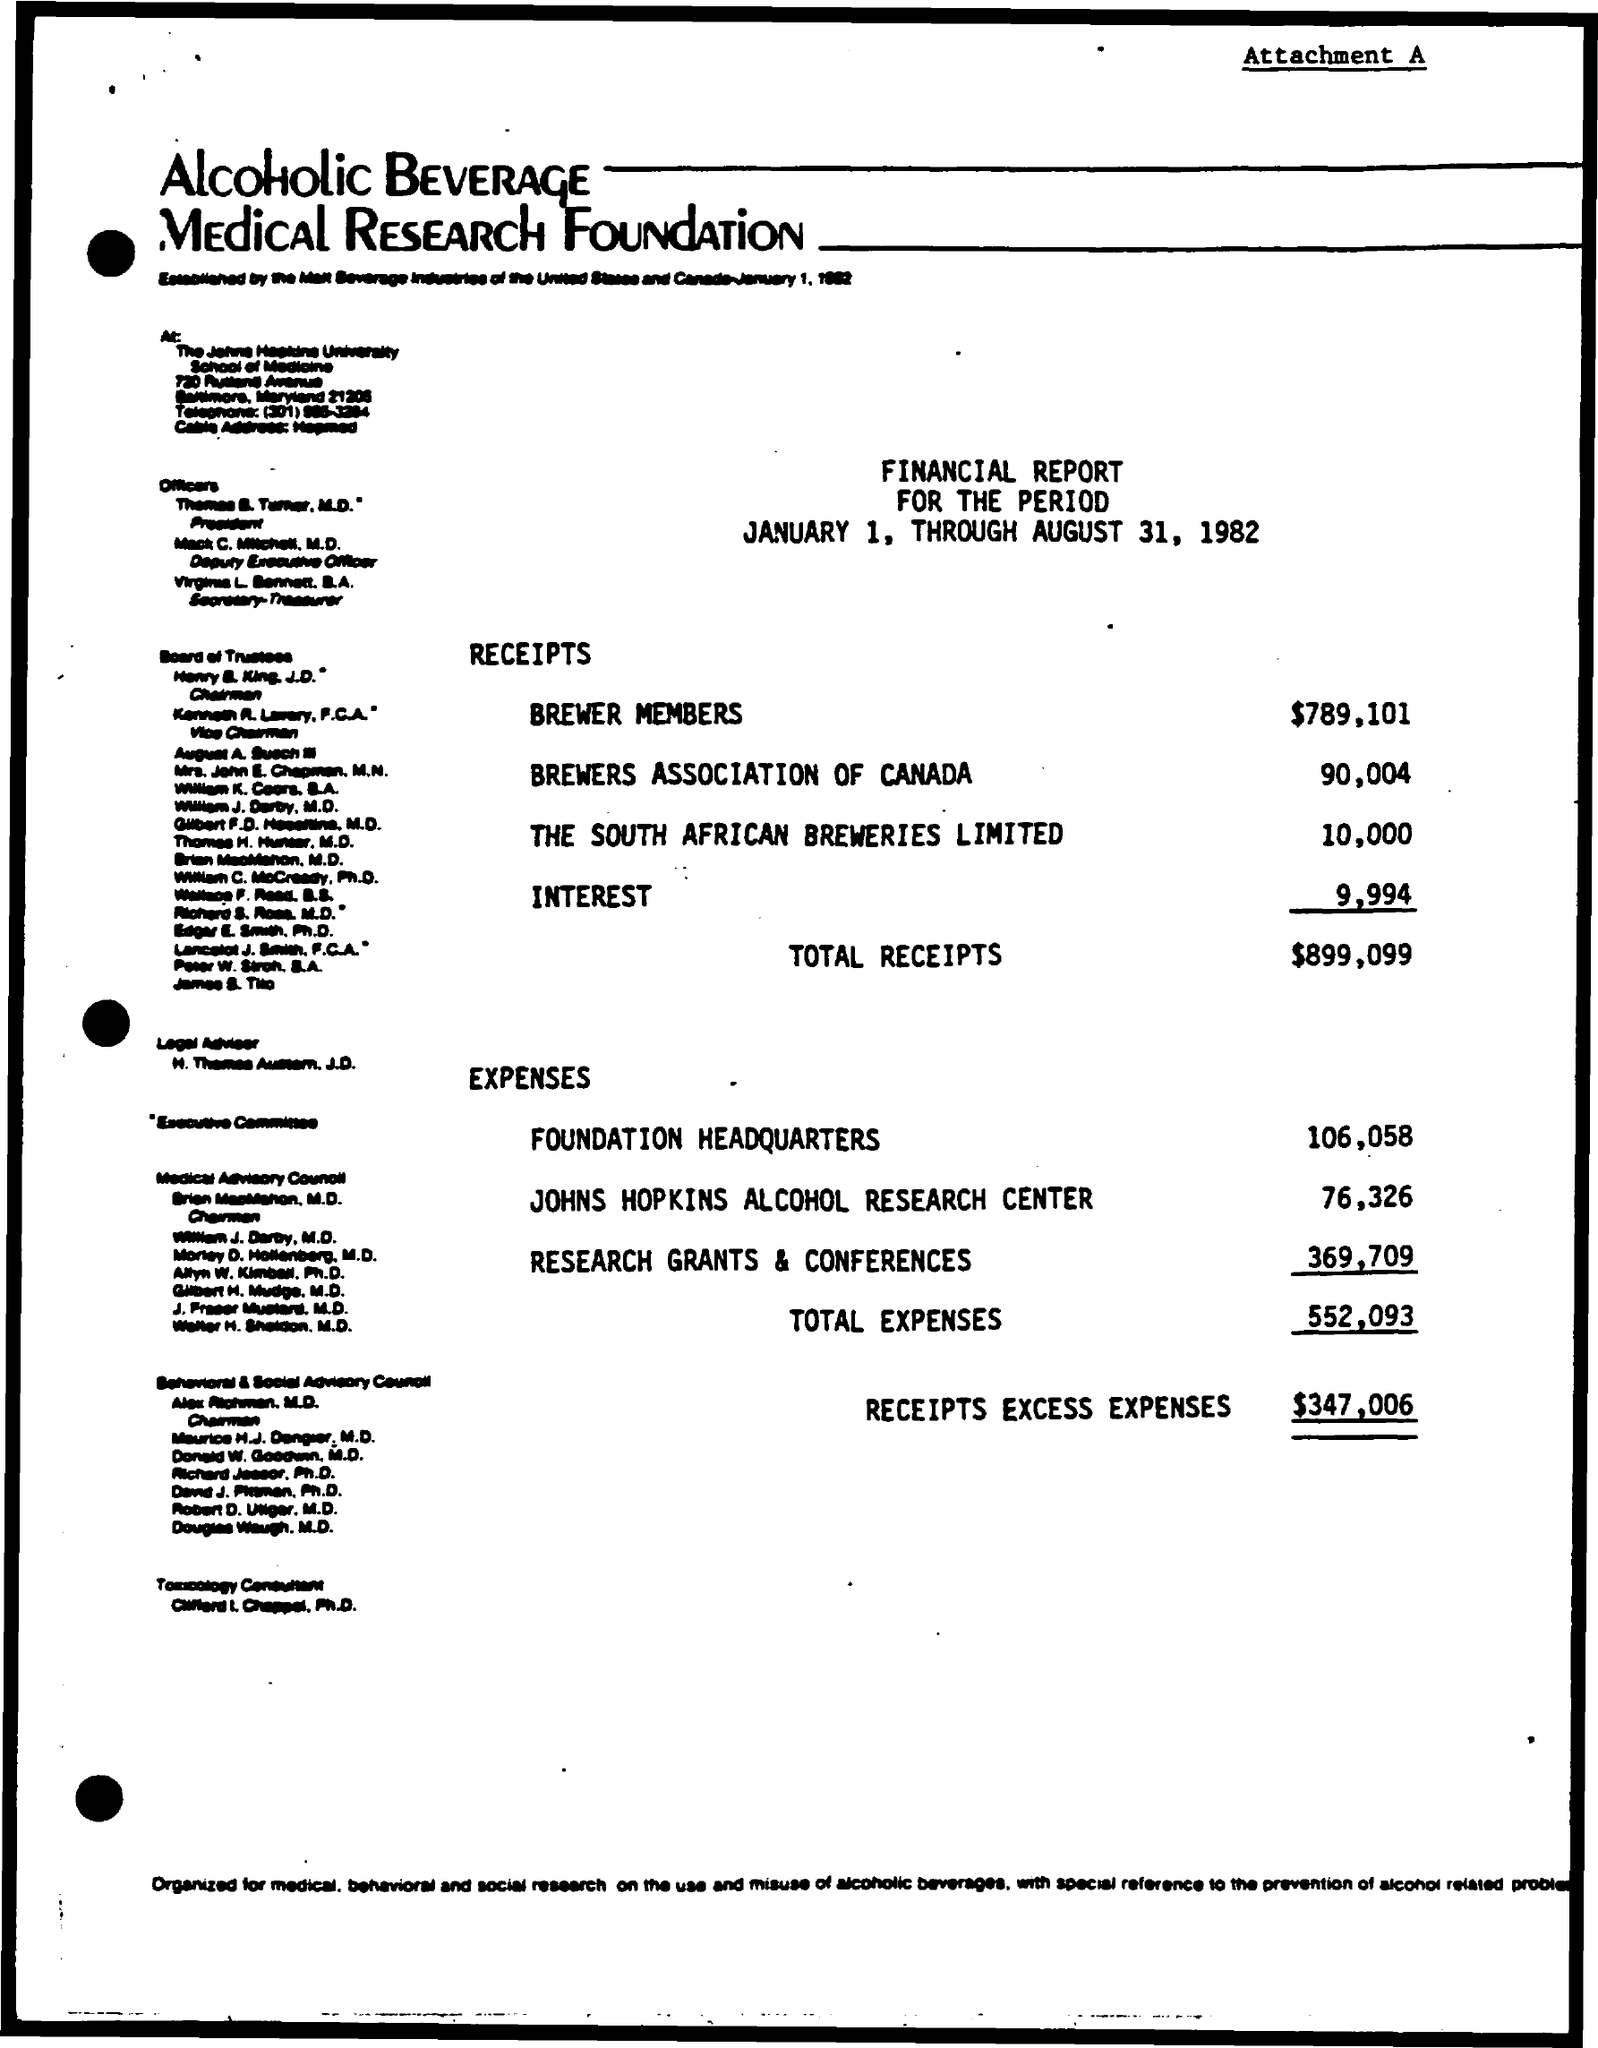What is the date on the document?
Offer a terse response. January 1, through august 31, 1982. What is the Amount for Brewer Members?
Keep it short and to the point. $789,101. What is the Amount for Brewer Association of Canada?
Keep it short and to the point. 90,004. What is the Amount for The south African Brewers Limited?
Make the answer very short. 10,000. What is the Interest?
Your answer should be very brief. 9,994. What are the Total Receipts?
Your answer should be compact. $899,099. What are the Expenses for foundation Headquarters?
Provide a short and direct response. 106,058. What are the Expenses for John Hopkins Alcohol Research Center?
Your response must be concise. 76,326. What are the Expenses for Research grants and conferences?
Provide a short and direct response. 369,709. What are the Total EXPENSES?
Provide a short and direct response. 552,093. 